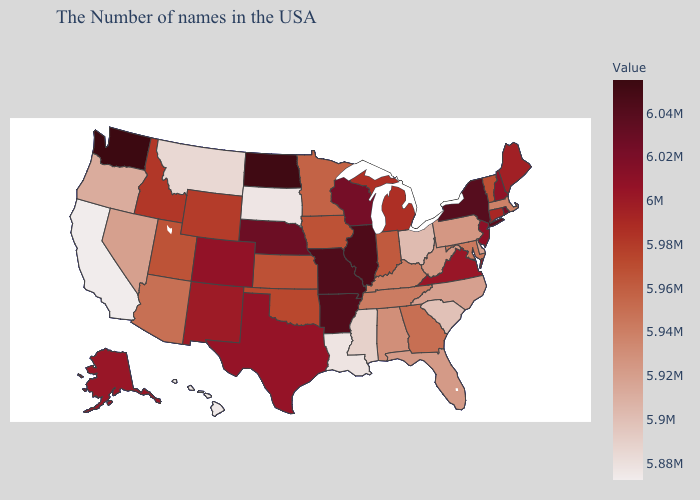Does Massachusetts have the lowest value in the Northeast?
Quick response, please. No. Does Washington have the highest value in the West?
Answer briefly. Yes. Which states have the highest value in the USA?
Concise answer only. Washington. Is the legend a continuous bar?
Quick response, please. Yes. Among the states that border Arizona , does Colorado have the highest value?
Write a very short answer. Yes. Which states have the highest value in the USA?
Keep it brief. Washington. 